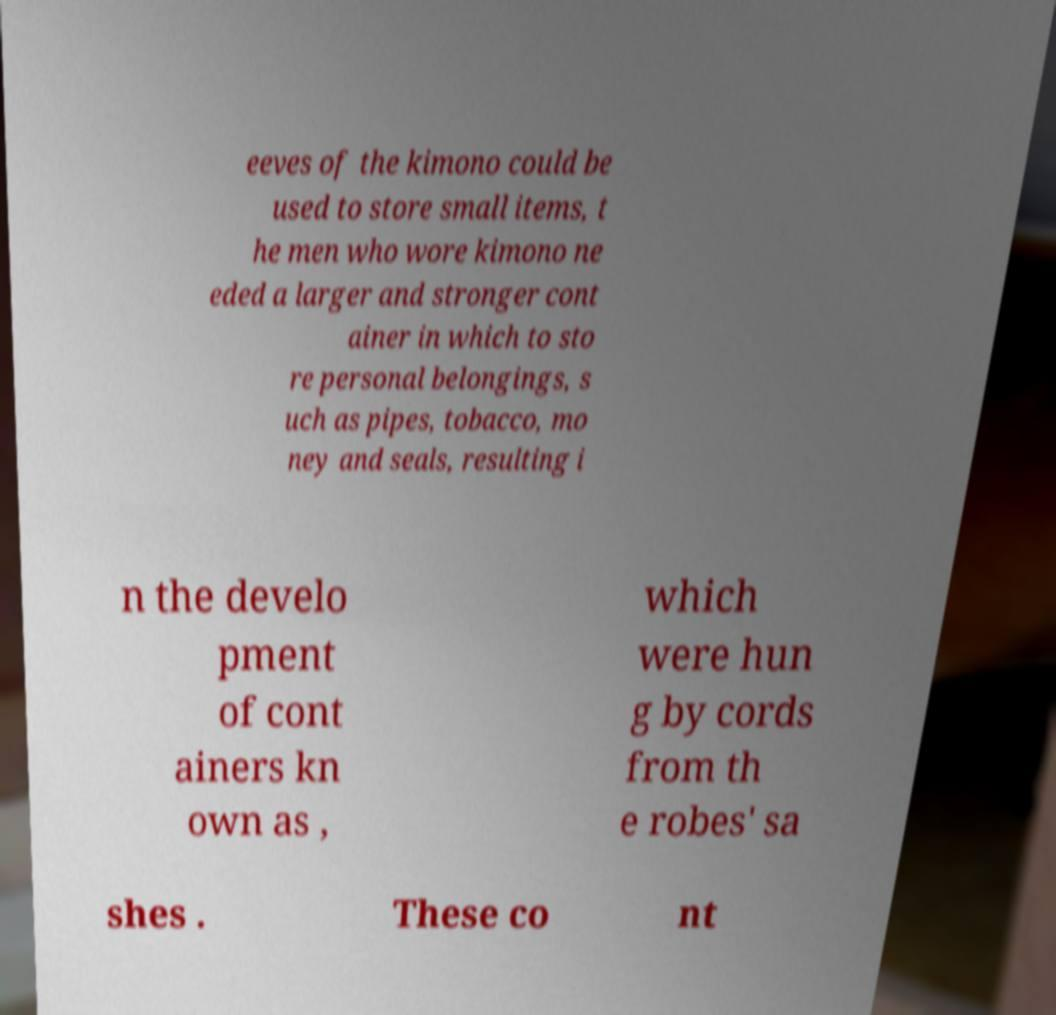For documentation purposes, I need the text within this image transcribed. Could you provide that? eeves of the kimono could be used to store small items, t he men who wore kimono ne eded a larger and stronger cont ainer in which to sto re personal belongings, s uch as pipes, tobacco, mo ney and seals, resulting i n the develo pment of cont ainers kn own as , which were hun g by cords from th e robes' sa shes . These co nt 